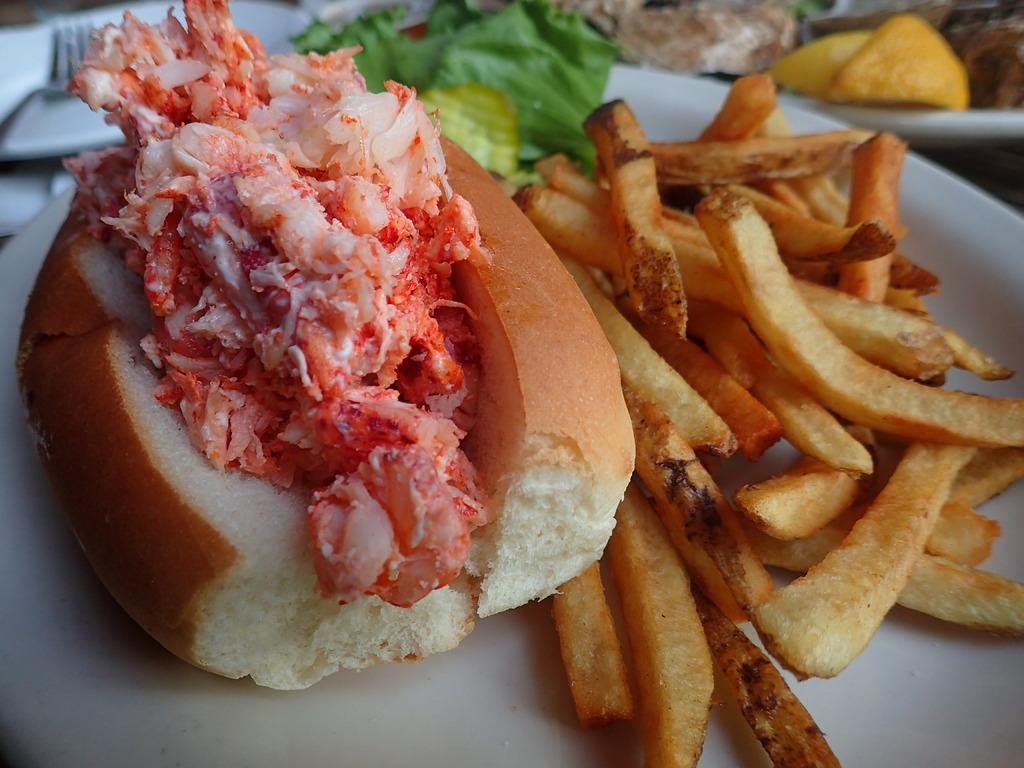What type of sandwich is in the image? There is a meat sandwich in the image. What other food items are visible in the image? There are french fries and a salad in the image. How are the food items arranged in the image? The food items are on a plate. What additional items can be seen behind the plate? There are plates and forks visible behind the plate. What impulse does the meat sandwich have in the image? The meat sandwich does not have any impulses in the image; it is an inanimate object. 